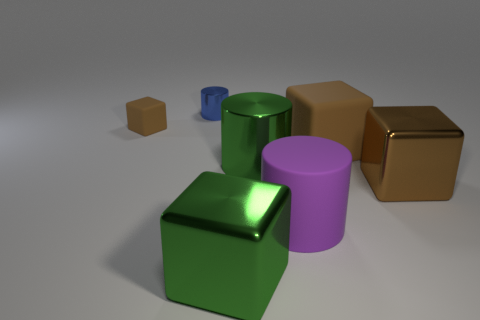Subtract all cyan spheres. How many brown blocks are left? 3 Add 2 tiny blue metal objects. How many objects exist? 9 Subtract all cylinders. How many objects are left? 4 Add 6 shiny cubes. How many shiny cubes exist? 8 Subtract 0 red cubes. How many objects are left? 7 Subtract all metallic cubes. Subtract all small shiny things. How many objects are left? 4 Add 6 green cylinders. How many green cylinders are left? 7 